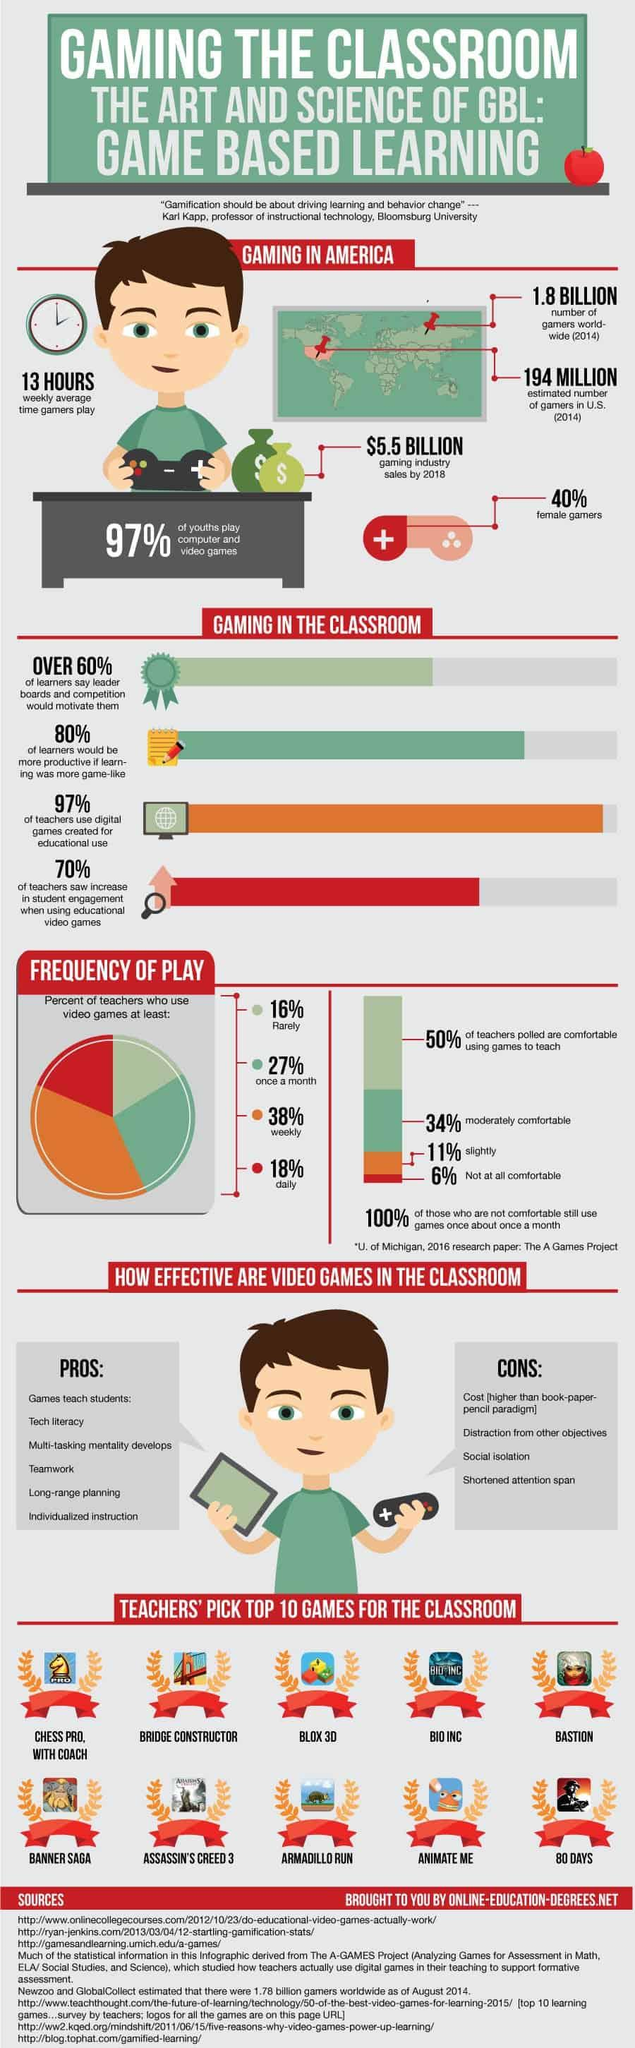Draw attention to some important aspects in this diagram. According to a recent survey, over 60% of gamers in America are males. According to a recent survey in the United States, approximately 27% of teachers report using video games at least once a month. In 2014, it is estimated that there were 194 million gamers in the United States. According to recent data, only 3% of teachers in America fail to utilize digital games created for educational purposes. According to a recent survey, only 3% of youths in the United States do not play computer or video games. 